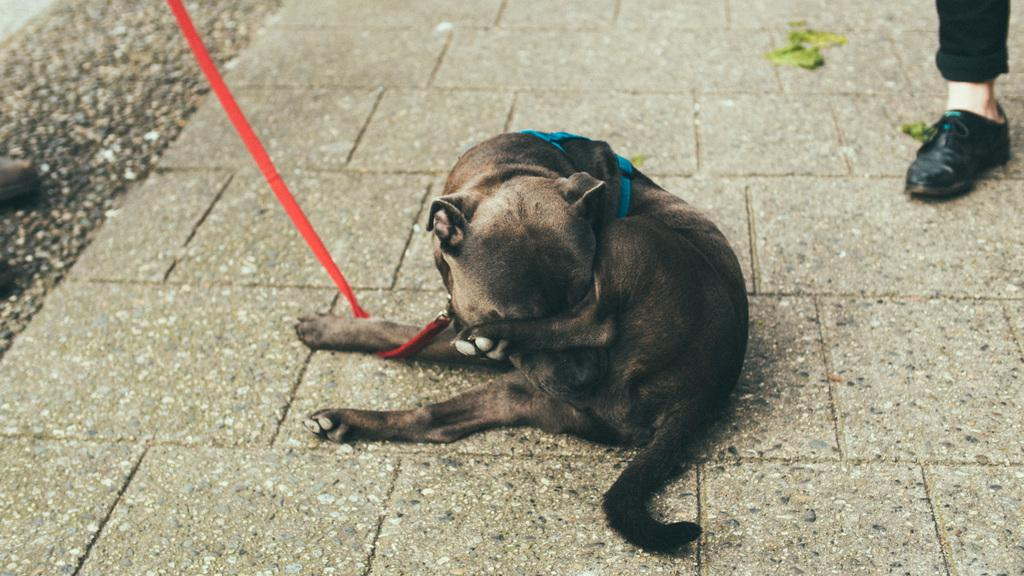What type of animal is in the image? There is an animal in the image, but the specific type cannot be determined from the provided facts. Where is the animal located in the image? The animal is sitting on the floor. How is the animal secured in the image? The animal is tied with a belt. Can you see any part of a person in the image? Yes, a person's leg is visible in the image. What is the animal's income in the image? Animals do not have income, so this question cannot be answered. 